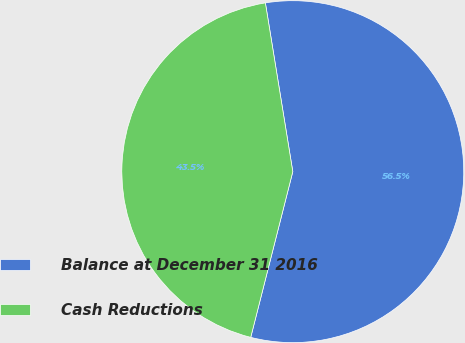Convert chart to OTSL. <chart><loc_0><loc_0><loc_500><loc_500><pie_chart><fcel>Balance at December 31 2016<fcel>Cash Reductions<nl><fcel>56.52%<fcel>43.48%<nl></chart> 